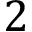<formula> <loc_0><loc_0><loc_500><loc_500>2</formula> 